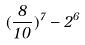<formula> <loc_0><loc_0><loc_500><loc_500>( \frac { 8 } { 1 0 } ) ^ { 7 } - 2 ^ { 6 }</formula> 